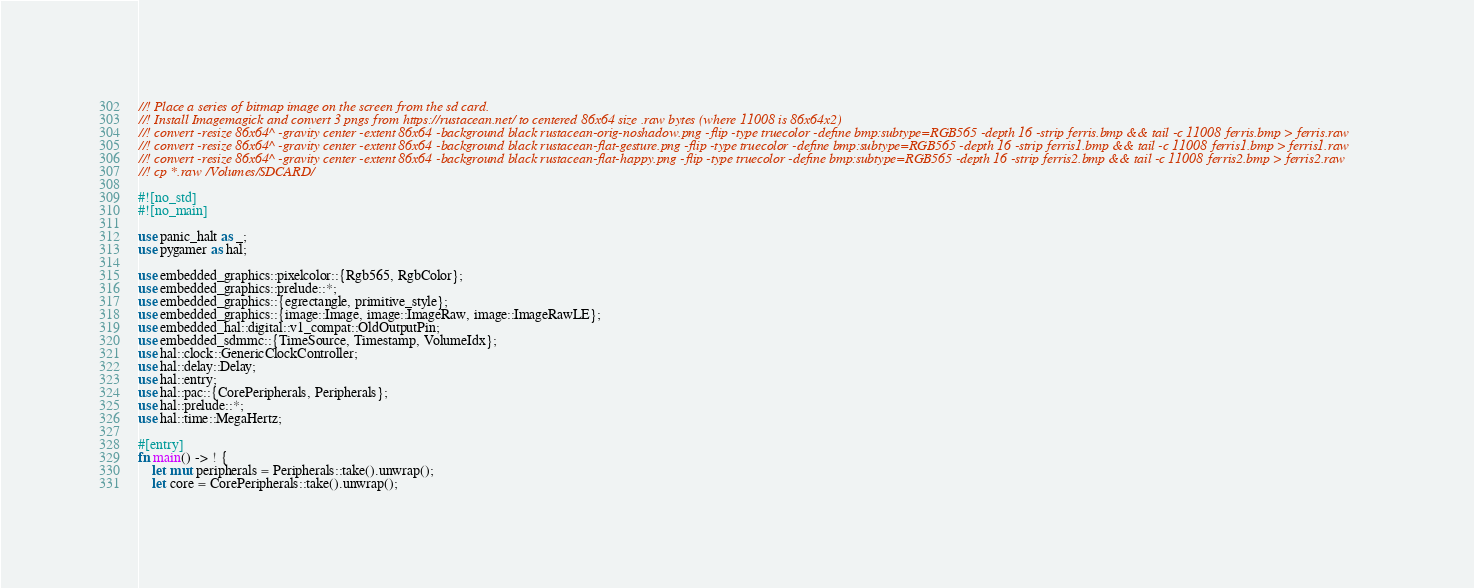Convert code to text. <code><loc_0><loc_0><loc_500><loc_500><_Rust_>//! Place a series of bitmap image on the screen from the sd card.
//! Install Imagemagick and convert 3 pngs from https://rustacean.net/ to centered 86x64 size .raw bytes (where 11008 is 86x64x2)
//! convert -resize 86x64^ -gravity center -extent 86x64 -background black rustacean-orig-noshadow.png -flip -type truecolor -define bmp:subtype=RGB565 -depth 16 -strip ferris.bmp && tail -c 11008 ferris.bmp > ferris.raw
//! convert -resize 86x64^ -gravity center -extent 86x64 -background black rustacean-flat-gesture.png -flip -type truecolor -define bmp:subtype=RGB565 -depth 16 -strip ferris1.bmp && tail -c 11008 ferris1.bmp > ferris1.raw
//! convert -resize 86x64^ -gravity center -extent 86x64 -background black rustacean-flat-happy.png -flip -type truecolor -define bmp:subtype=RGB565 -depth 16 -strip ferris2.bmp && tail -c 11008 ferris2.bmp > ferris2.raw
//! cp *.raw /Volumes/SDCARD/

#![no_std]
#![no_main]

use panic_halt as _;
use pygamer as hal;

use embedded_graphics::pixelcolor::{Rgb565, RgbColor};
use embedded_graphics::prelude::*;
use embedded_graphics::{egrectangle, primitive_style};
use embedded_graphics::{image::Image, image::ImageRaw, image::ImageRawLE};
use embedded_hal::digital::v1_compat::OldOutputPin;
use embedded_sdmmc::{TimeSource, Timestamp, VolumeIdx};
use hal::clock::GenericClockController;
use hal::delay::Delay;
use hal::entry;
use hal::pac::{CorePeripherals, Peripherals};
use hal::prelude::*;
use hal::time::MegaHertz;

#[entry]
fn main() -> ! {
    let mut peripherals = Peripherals::take().unwrap();
    let core = CorePeripherals::take().unwrap();</code> 